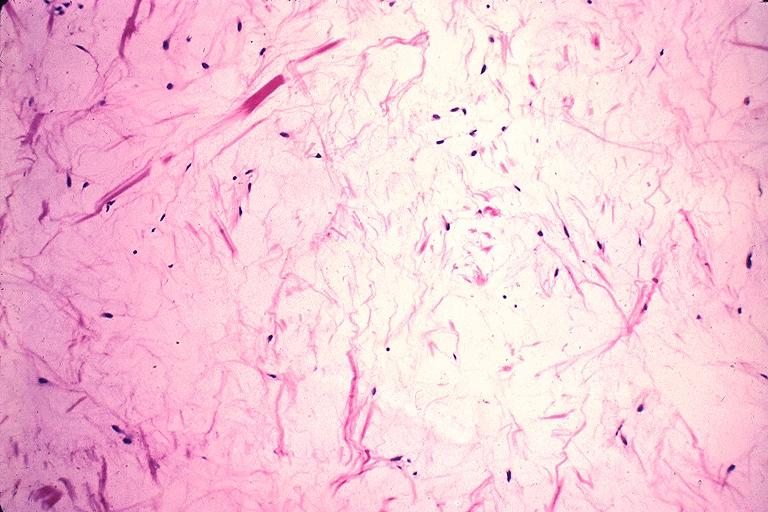where is this?
Answer the question using a single word or phrase. Oral 